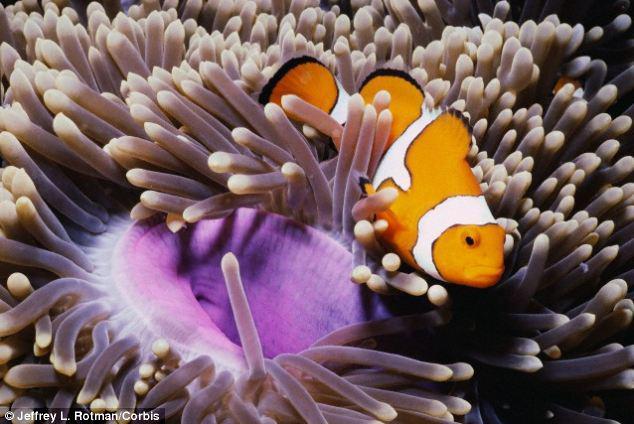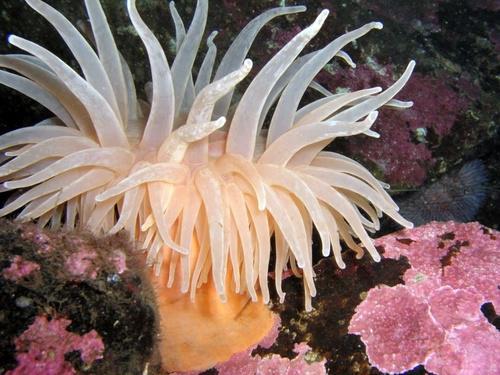The first image is the image on the left, the second image is the image on the right. For the images shown, is this caption "One of the images shows exactly one orange and white fish next to an urchin." true? Answer yes or no. Yes. The first image is the image on the left, the second image is the image on the right. Analyze the images presented: Is the assertion "There is a clownfish somewhere in the pair." valid? Answer yes or no. Yes. 